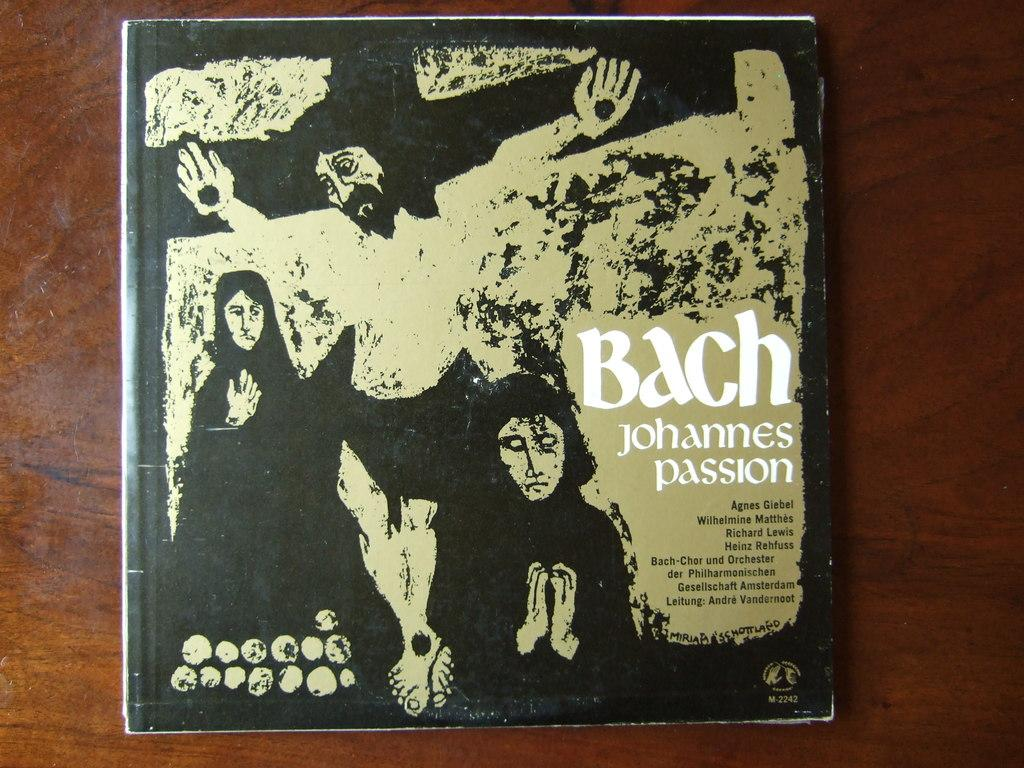What object can be seen on the table in the image? There is a book on the table in the image. What is depicted on the book cover? The book cover features a man tied to a cross symbol. What type of stocking is the man wearing on the book cover? There is no mention of stockings or clothing on the man in the book cover; he is tied to a cross symbol. 